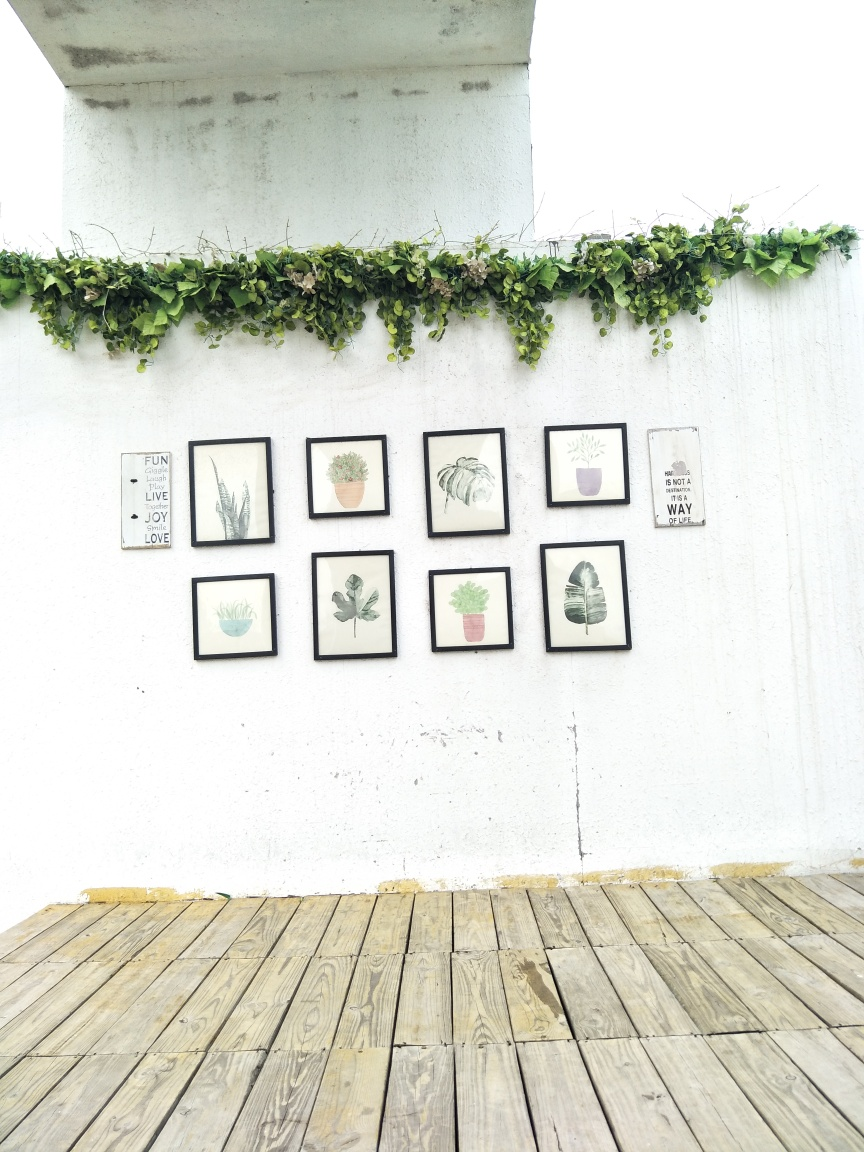What might have inspired the choice of plants for both the hanging greenery and the illustrated ones in the frames? The choice of plants in both the hanging greenery and the illustrations likely reflects a desire to evoke the tranquil and rejuvenating essence of nature within an indoor setting. The hanging plants, with their cascading leaves, introduce a dynamic and organic element, suggesting a connection with the outdoors. The illustrated plants are diverse yet complementary, possibly chosen for their aesthetic appeal and association with calmness and growth. Both selections aim to create a peaceful green oasis that can relax and inspire those in the vicinity. 